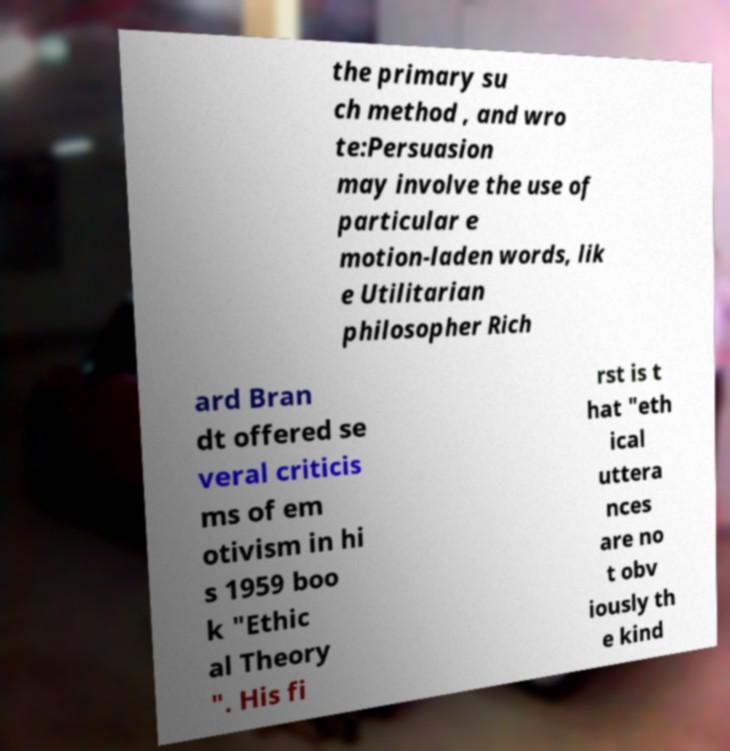I need the written content from this picture converted into text. Can you do that? the primary su ch method , and wro te:Persuasion may involve the use of particular e motion-laden words, lik e Utilitarian philosopher Rich ard Bran dt offered se veral criticis ms of em otivism in hi s 1959 boo k "Ethic al Theory ". His fi rst is t hat "eth ical uttera nces are no t obv iously th e kind 